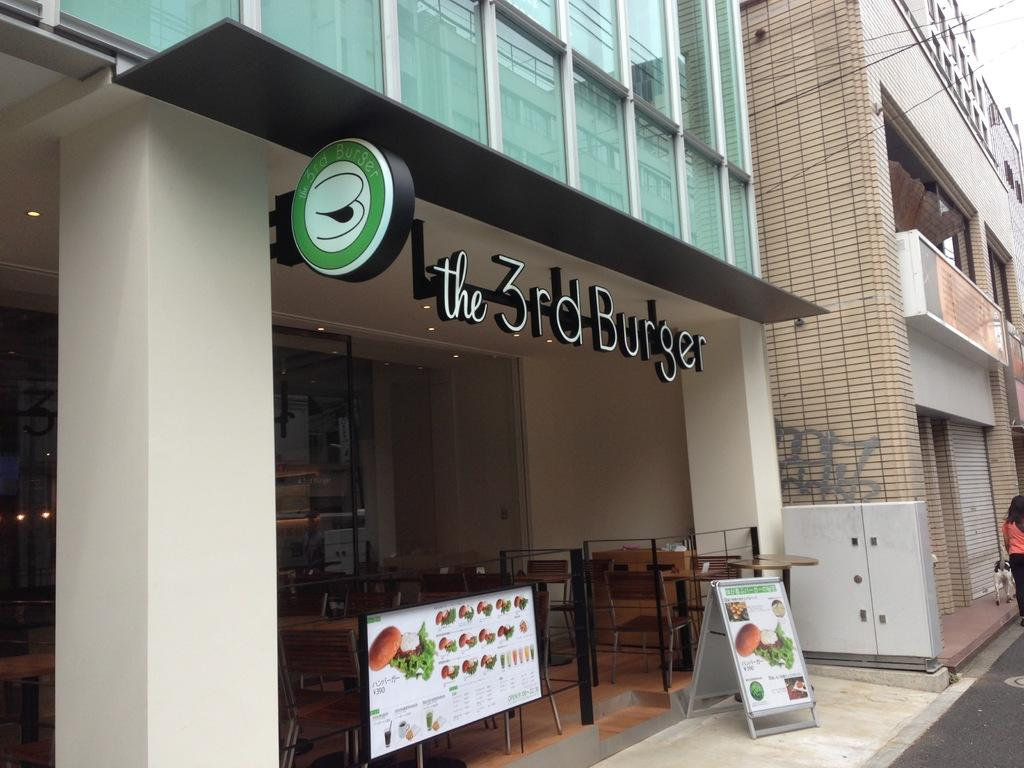What type of structures are present in the image? There are buildings in the image. What type of furniture can be seen in the image? There are chairs and tables in the image. What is placed in front of the buildings? There are boards in front of the buildings. Can you describe the person in the image? There is a person with a black and orange color dress in the image. What type of fear can be seen on the person's face in the image? There is no indication of fear on the person's face in the image. How does the zephyr affect the buildings in the image? There is no mention of a zephyr or any wind in the image, so its effect cannot be determined. 